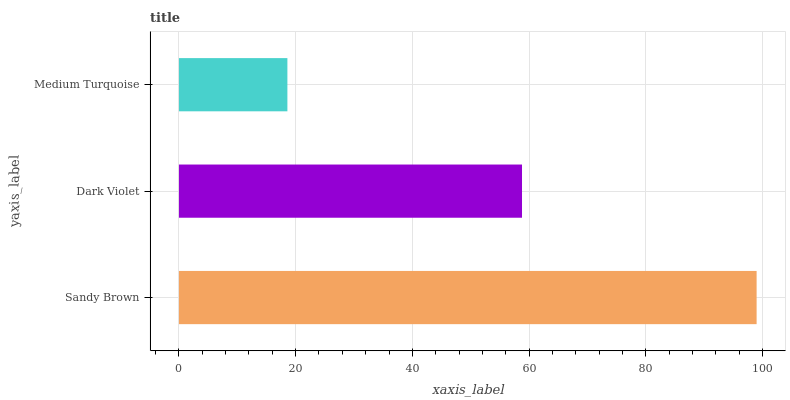Is Medium Turquoise the minimum?
Answer yes or no. Yes. Is Sandy Brown the maximum?
Answer yes or no. Yes. Is Dark Violet the minimum?
Answer yes or no. No. Is Dark Violet the maximum?
Answer yes or no. No. Is Sandy Brown greater than Dark Violet?
Answer yes or no. Yes. Is Dark Violet less than Sandy Brown?
Answer yes or no. Yes. Is Dark Violet greater than Sandy Brown?
Answer yes or no. No. Is Sandy Brown less than Dark Violet?
Answer yes or no. No. Is Dark Violet the high median?
Answer yes or no. Yes. Is Dark Violet the low median?
Answer yes or no. Yes. Is Sandy Brown the high median?
Answer yes or no. No. Is Sandy Brown the low median?
Answer yes or no. No. 